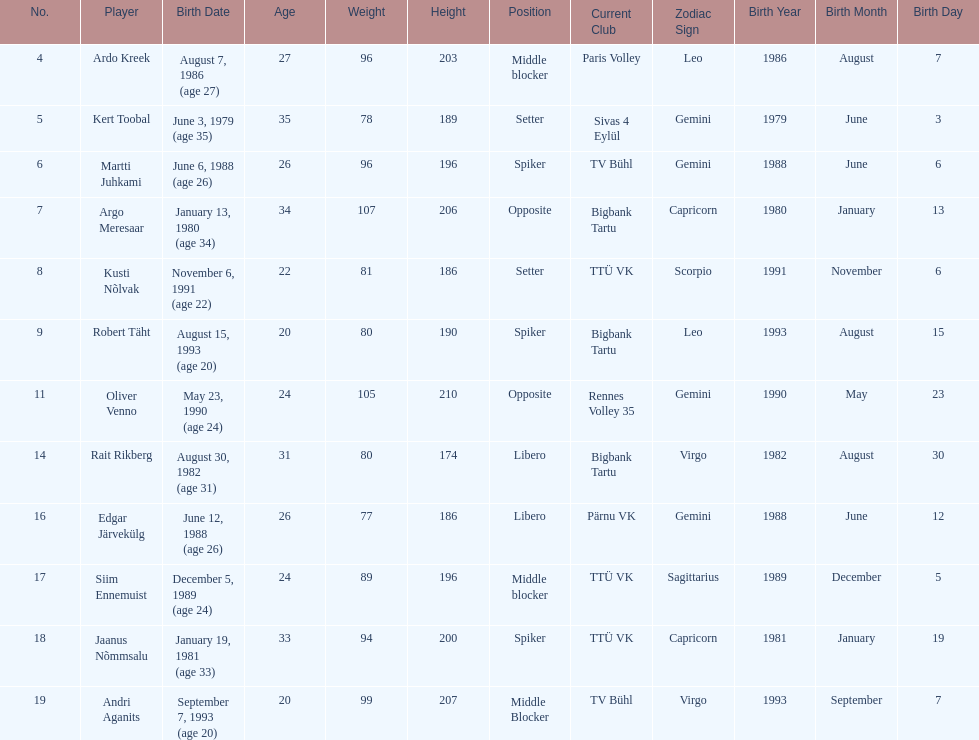How many players were born before 1988? 5. 